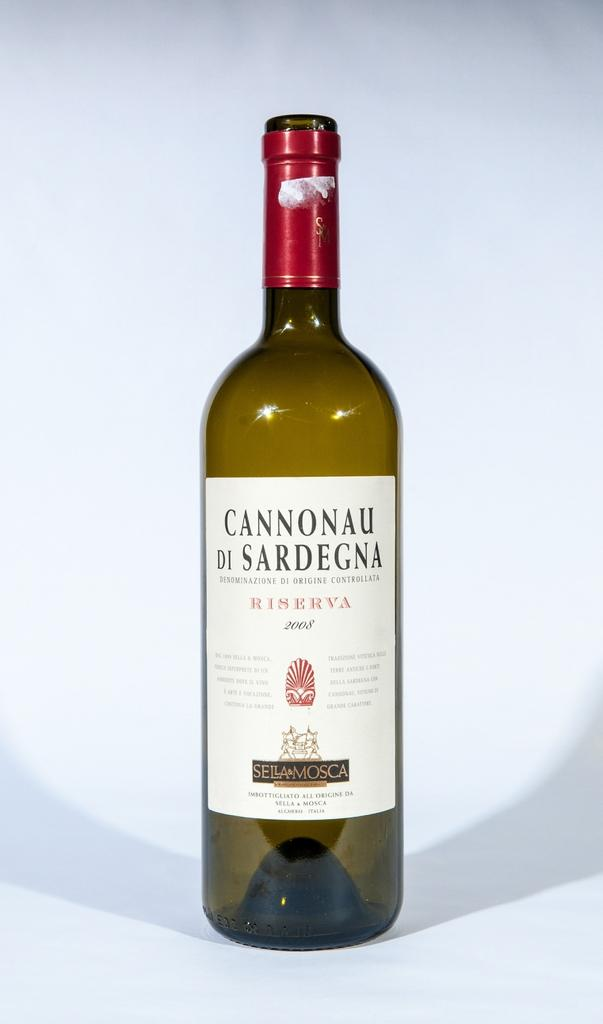Provide a one-sentence caption for the provided image. A bottle of wine is produced by Sella & Mosca. 